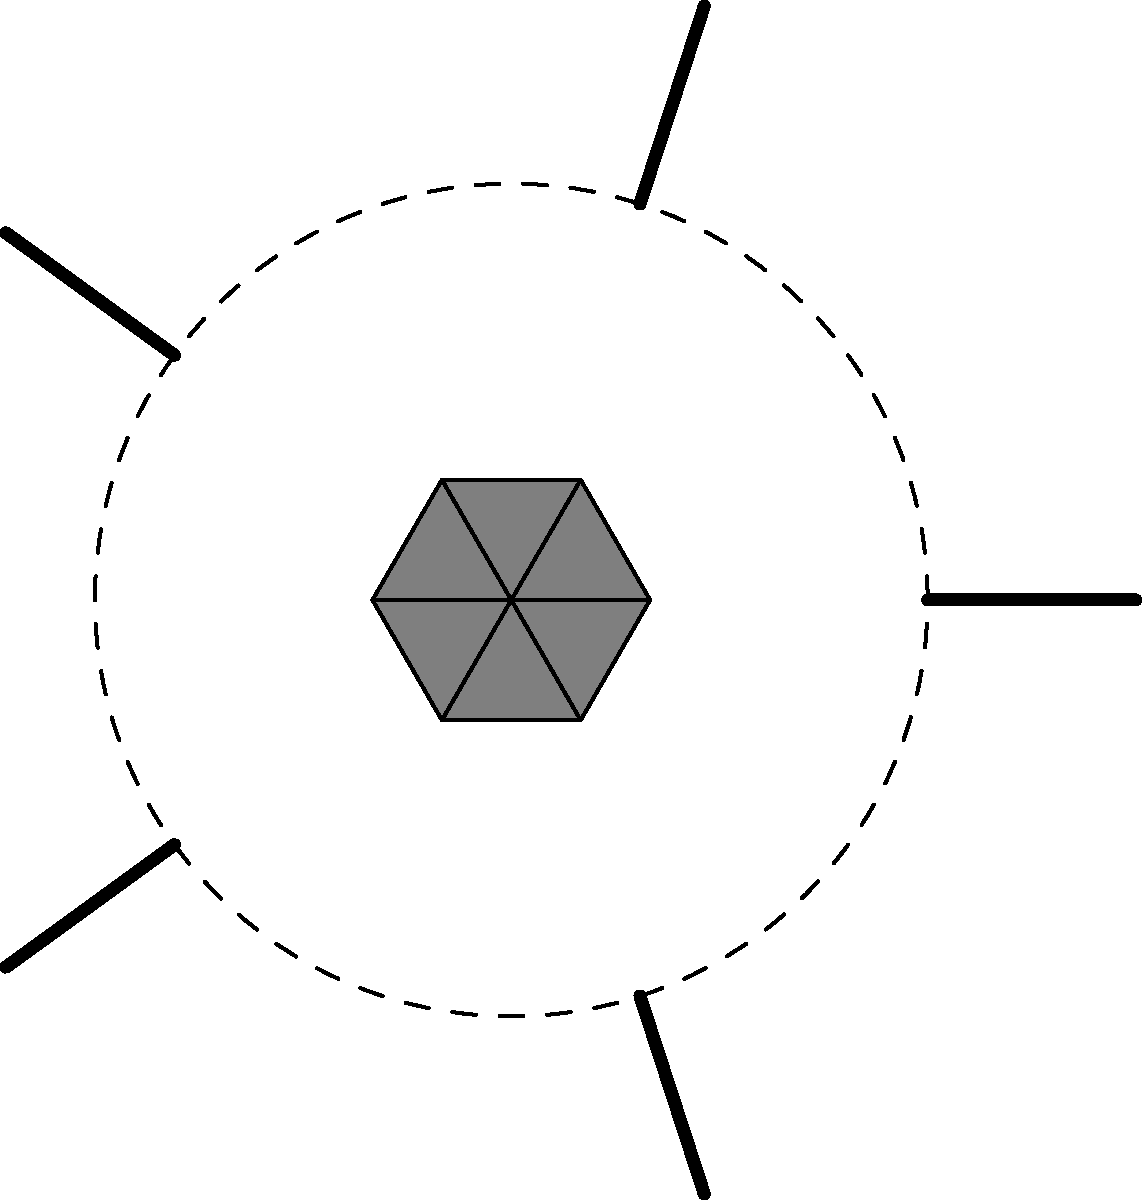In this tribal-inspired tattoo design, a pattern of triangles forms a central rosette. How many additional line segments should be added to complete the outer ring pattern? To solve this question, let's break it down step-by-step:

1. Observe the central rosette: It's made up of 6 equilateral triangles arranged in a circular pattern.

2. Look at the outer ring: There are straight line segments radiating outward from the central rosette.

3. Count the existing line segments: There are 5 line segments visible in the outer ring.

4. Determine the pattern: Given the circular nature of the design and the symmetry of the central rosette, we can infer that the outer ring should have a regular pattern.

5. Consider the symmetry: The most likely symmetric pattern would divide the circle into equal parts.

6. Relate to the central rosette: The central rosette has 6-fold symmetry (6 triangles).

7. Conclude the pattern: To maintain consistency with the central design, the outer ring should also have 6-fold symmetry.

8. Calculate missing segments: If the outer ring should have 6 segments for 6-fold symmetry, and we already see 5 segments, then 1 more segment needs to be added.

Therefore, 1 additional line segment should be added to complete the outer ring pattern in a way that's consistent with the tribal-inspired design's symmetry.
Answer: 1 